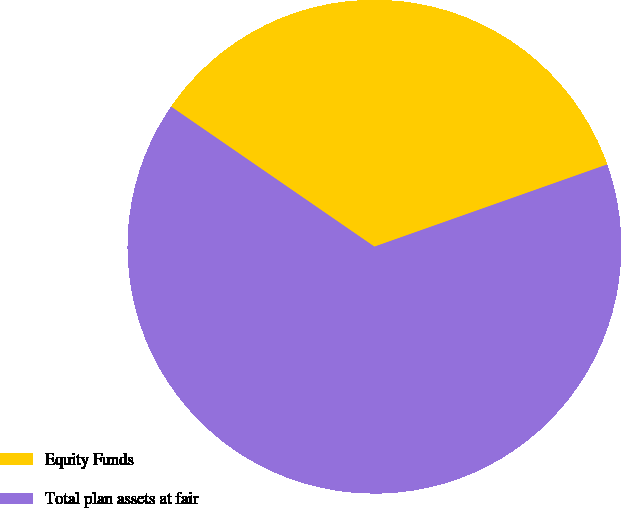Convert chart. <chart><loc_0><loc_0><loc_500><loc_500><pie_chart><fcel>Equity Funds<fcel>Total plan assets at fair<nl><fcel>35.0%<fcel>65.0%<nl></chart> 